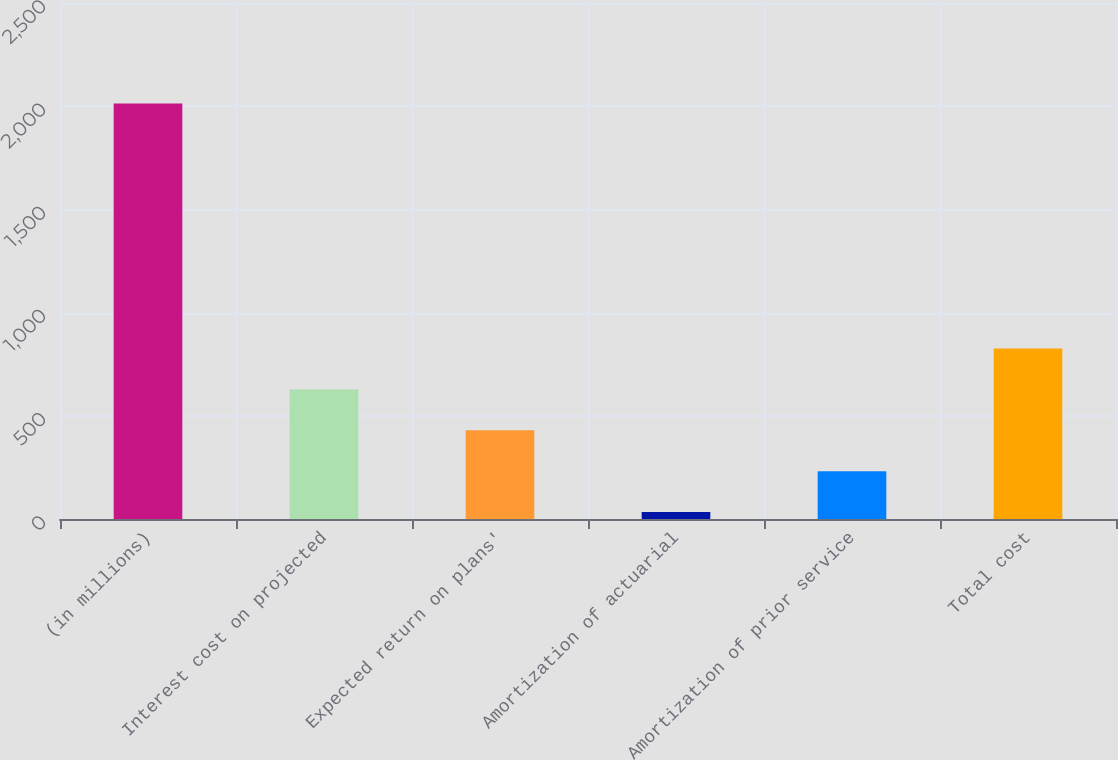Convert chart. <chart><loc_0><loc_0><loc_500><loc_500><bar_chart><fcel>(in millions)<fcel>Interest cost on projected<fcel>Expected return on plans'<fcel>Amortization of actuarial<fcel>Amortization of prior service<fcel>Total cost<nl><fcel>2013<fcel>627.7<fcel>429.8<fcel>34<fcel>231.9<fcel>825.6<nl></chart> 